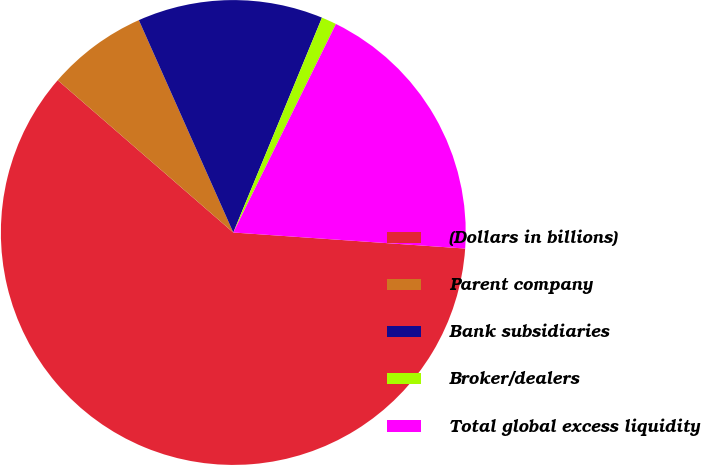Convert chart. <chart><loc_0><loc_0><loc_500><loc_500><pie_chart><fcel>(Dollars in billions)<fcel>Parent company<fcel>Bank subsidiaries<fcel>Broker/dealers<fcel>Total global excess liquidity<nl><fcel>60.27%<fcel>6.97%<fcel>12.89%<fcel>1.05%<fcel>18.82%<nl></chart> 